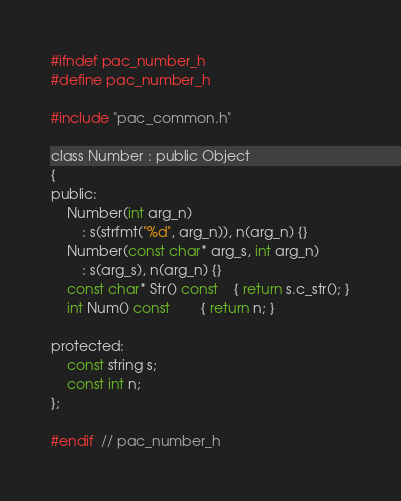<code> <loc_0><loc_0><loc_500><loc_500><_C_>#ifndef pac_number_h
#define pac_number_h

#include "pac_common.h"

class Number : public Object
{
public:
	Number(int arg_n)
		: s(strfmt("%d", arg_n)), n(arg_n) {}
	Number(const char* arg_s, int arg_n)
		: s(arg_s), n(arg_n) {}
	const char* Str() const 	{ return s.c_str(); }
	int Num() const 		{ return n; }

protected:
	const string s;
	const int n;
};

#endif  // pac_number_h
</code> 